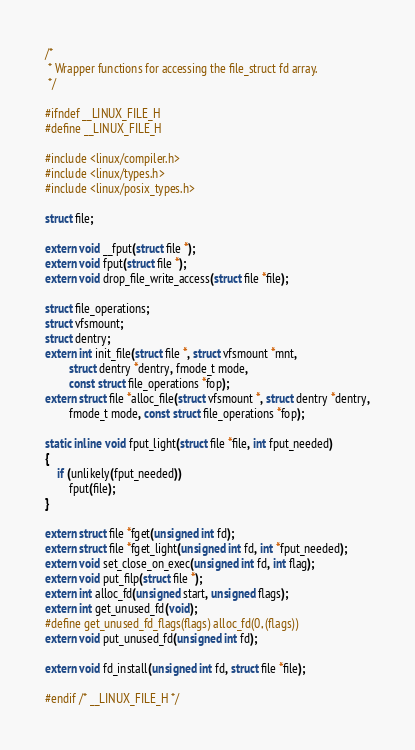Convert code to text. <code><loc_0><loc_0><loc_500><loc_500><_C_>/*
 * Wrapper functions for accessing the file_struct fd array.
 */

#ifndef __LINUX_FILE_H
#define __LINUX_FILE_H

#include <linux/compiler.h>
#include <linux/types.h>
#include <linux/posix_types.h>

struct file;

extern void __fput(struct file *);
extern void fput(struct file *);
extern void drop_file_write_access(struct file *file);

struct file_operations;
struct vfsmount;
struct dentry;
extern int init_file(struct file *, struct vfsmount *mnt,
		struct dentry *dentry, fmode_t mode,
		const struct file_operations *fop);
extern struct file *alloc_file(struct vfsmount *, struct dentry *dentry,
		fmode_t mode, const struct file_operations *fop);

static inline void fput_light(struct file *file, int fput_needed)
{
	if (unlikely(fput_needed))
		fput(file);
}

extern struct file *fget(unsigned int fd);
extern struct file *fget_light(unsigned int fd, int *fput_needed);
extern void set_close_on_exec(unsigned int fd, int flag);
extern void put_filp(struct file *);
extern int alloc_fd(unsigned start, unsigned flags);
extern int get_unused_fd(void);
#define get_unused_fd_flags(flags) alloc_fd(0, (flags))
extern void put_unused_fd(unsigned int fd);

extern void fd_install(unsigned int fd, struct file *file);

#endif /* __LINUX_FILE_H */
</code> 